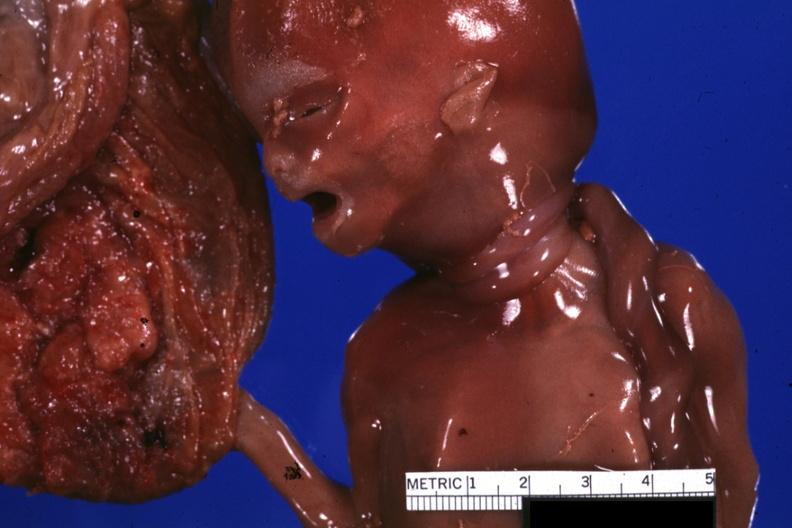does this image show close-up of two loops of umbilical cord around neck?
Answer the question using a single word or phrase. Yes 